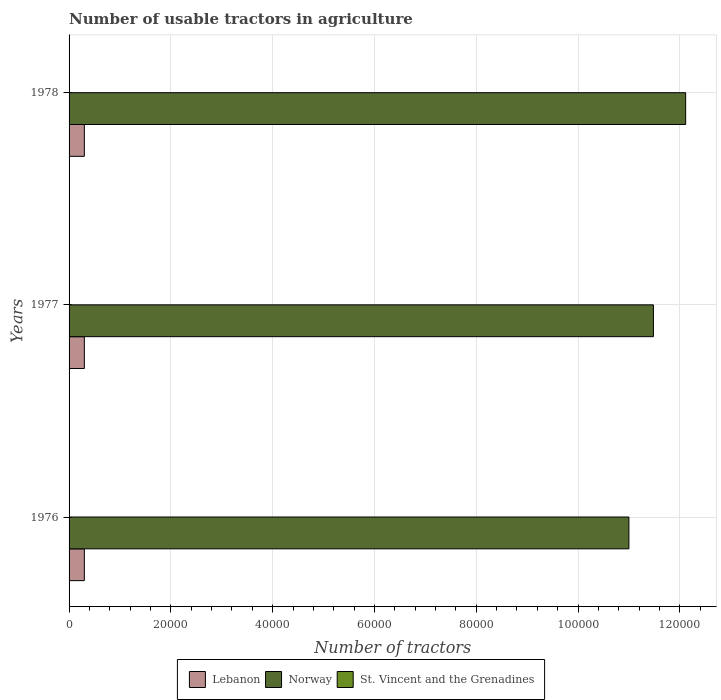How many groups of bars are there?
Make the answer very short. 3. Are the number of bars per tick equal to the number of legend labels?
Offer a very short reply. Yes. Are the number of bars on each tick of the Y-axis equal?
Your answer should be compact. Yes. How many bars are there on the 1st tick from the top?
Offer a very short reply. 3. How many bars are there on the 3rd tick from the bottom?
Offer a terse response. 3. What is the number of usable tractors in agriculture in Lebanon in 1977?
Provide a short and direct response. 3000. Across all years, what is the maximum number of usable tractors in agriculture in Lebanon?
Make the answer very short. 3000. Across all years, what is the minimum number of usable tractors in agriculture in Lebanon?
Offer a very short reply. 3000. In which year was the number of usable tractors in agriculture in Lebanon maximum?
Offer a terse response. 1976. In which year was the number of usable tractors in agriculture in Lebanon minimum?
Give a very brief answer. 1976. What is the total number of usable tractors in agriculture in St. Vincent and the Grenadines in the graph?
Make the answer very short. 219. What is the difference between the number of usable tractors in agriculture in St. Vincent and the Grenadines in 1976 and that in 1977?
Offer a very short reply. -1. What is the difference between the number of usable tractors in agriculture in Norway in 1978 and the number of usable tractors in agriculture in St. Vincent and the Grenadines in 1976?
Give a very brief answer. 1.21e+05. What is the average number of usable tractors in agriculture in Norway per year?
Offer a terse response. 1.15e+05. In the year 1977, what is the difference between the number of usable tractors in agriculture in St. Vincent and the Grenadines and number of usable tractors in agriculture in Norway?
Provide a short and direct response. -1.15e+05. What is the ratio of the number of usable tractors in agriculture in St. Vincent and the Grenadines in 1976 to that in 1977?
Provide a short and direct response. 0.99. Is the number of usable tractors in agriculture in Lebanon in 1976 less than that in 1977?
Keep it short and to the point. No. What is the difference between the highest and the second highest number of usable tractors in agriculture in Lebanon?
Your response must be concise. 0. What is the difference between the highest and the lowest number of usable tractors in agriculture in Norway?
Offer a very short reply. 1.12e+04. What does the 3rd bar from the top in 1978 represents?
Keep it short and to the point. Lebanon. What does the 3rd bar from the bottom in 1976 represents?
Your answer should be compact. St. Vincent and the Grenadines. Is it the case that in every year, the sum of the number of usable tractors in agriculture in St. Vincent and the Grenadines and number of usable tractors in agriculture in Norway is greater than the number of usable tractors in agriculture in Lebanon?
Provide a succinct answer. Yes. Does the graph contain any zero values?
Offer a very short reply. No. Does the graph contain grids?
Give a very brief answer. Yes. How many legend labels are there?
Offer a terse response. 3. What is the title of the graph?
Offer a terse response. Number of usable tractors in agriculture. What is the label or title of the X-axis?
Provide a short and direct response. Number of tractors. What is the Number of tractors of Lebanon in 1976?
Ensure brevity in your answer.  3000. What is the Number of tractors of Norway in 1976?
Give a very brief answer. 1.10e+05. What is the Number of tractors of Lebanon in 1977?
Keep it short and to the point. 3000. What is the Number of tractors in Norway in 1977?
Your response must be concise. 1.15e+05. What is the Number of tractors of St. Vincent and the Grenadines in 1977?
Ensure brevity in your answer.  73. What is the Number of tractors in Lebanon in 1978?
Give a very brief answer. 3000. What is the Number of tractors of Norway in 1978?
Offer a terse response. 1.21e+05. Across all years, what is the maximum Number of tractors of Lebanon?
Your response must be concise. 3000. Across all years, what is the maximum Number of tractors of Norway?
Your answer should be compact. 1.21e+05. Across all years, what is the minimum Number of tractors in Lebanon?
Your answer should be very brief. 3000. Across all years, what is the minimum Number of tractors in Norway?
Provide a succinct answer. 1.10e+05. What is the total Number of tractors of Lebanon in the graph?
Provide a succinct answer. 9000. What is the total Number of tractors of Norway in the graph?
Provide a short and direct response. 3.46e+05. What is the total Number of tractors of St. Vincent and the Grenadines in the graph?
Provide a short and direct response. 219. What is the difference between the Number of tractors in Norway in 1976 and that in 1977?
Make the answer very short. -4816. What is the difference between the Number of tractors in St. Vincent and the Grenadines in 1976 and that in 1977?
Offer a very short reply. -1. What is the difference between the Number of tractors of Norway in 1976 and that in 1978?
Provide a succinct answer. -1.12e+04. What is the difference between the Number of tractors of St. Vincent and the Grenadines in 1976 and that in 1978?
Make the answer very short. -2. What is the difference between the Number of tractors of Norway in 1977 and that in 1978?
Ensure brevity in your answer.  -6335. What is the difference between the Number of tractors in Lebanon in 1976 and the Number of tractors in Norway in 1977?
Give a very brief answer. -1.12e+05. What is the difference between the Number of tractors in Lebanon in 1976 and the Number of tractors in St. Vincent and the Grenadines in 1977?
Ensure brevity in your answer.  2927. What is the difference between the Number of tractors in Norway in 1976 and the Number of tractors in St. Vincent and the Grenadines in 1977?
Your answer should be very brief. 1.10e+05. What is the difference between the Number of tractors of Lebanon in 1976 and the Number of tractors of Norway in 1978?
Your answer should be very brief. -1.18e+05. What is the difference between the Number of tractors in Lebanon in 1976 and the Number of tractors in St. Vincent and the Grenadines in 1978?
Give a very brief answer. 2926. What is the difference between the Number of tractors of Norway in 1976 and the Number of tractors of St. Vincent and the Grenadines in 1978?
Offer a terse response. 1.10e+05. What is the difference between the Number of tractors in Lebanon in 1977 and the Number of tractors in Norway in 1978?
Your answer should be compact. -1.18e+05. What is the difference between the Number of tractors in Lebanon in 1977 and the Number of tractors in St. Vincent and the Grenadines in 1978?
Your answer should be very brief. 2926. What is the difference between the Number of tractors in Norway in 1977 and the Number of tractors in St. Vincent and the Grenadines in 1978?
Your answer should be very brief. 1.15e+05. What is the average Number of tractors of Lebanon per year?
Offer a terse response. 3000. What is the average Number of tractors of Norway per year?
Your response must be concise. 1.15e+05. What is the average Number of tractors in St. Vincent and the Grenadines per year?
Your answer should be very brief. 73. In the year 1976, what is the difference between the Number of tractors in Lebanon and Number of tractors in Norway?
Keep it short and to the point. -1.07e+05. In the year 1976, what is the difference between the Number of tractors in Lebanon and Number of tractors in St. Vincent and the Grenadines?
Make the answer very short. 2928. In the year 1976, what is the difference between the Number of tractors of Norway and Number of tractors of St. Vincent and the Grenadines?
Keep it short and to the point. 1.10e+05. In the year 1977, what is the difference between the Number of tractors in Lebanon and Number of tractors in Norway?
Offer a very short reply. -1.12e+05. In the year 1977, what is the difference between the Number of tractors of Lebanon and Number of tractors of St. Vincent and the Grenadines?
Your answer should be compact. 2927. In the year 1977, what is the difference between the Number of tractors of Norway and Number of tractors of St. Vincent and the Grenadines?
Make the answer very short. 1.15e+05. In the year 1978, what is the difference between the Number of tractors of Lebanon and Number of tractors of Norway?
Your answer should be very brief. -1.18e+05. In the year 1978, what is the difference between the Number of tractors in Lebanon and Number of tractors in St. Vincent and the Grenadines?
Provide a succinct answer. 2926. In the year 1978, what is the difference between the Number of tractors of Norway and Number of tractors of St. Vincent and the Grenadines?
Ensure brevity in your answer.  1.21e+05. What is the ratio of the Number of tractors in Lebanon in 1976 to that in 1977?
Offer a very short reply. 1. What is the ratio of the Number of tractors of Norway in 1976 to that in 1977?
Your answer should be compact. 0.96. What is the ratio of the Number of tractors in St. Vincent and the Grenadines in 1976 to that in 1977?
Your response must be concise. 0.99. What is the ratio of the Number of tractors of Norway in 1976 to that in 1978?
Offer a very short reply. 0.91. What is the ratio of the Number of tractors of St. Vincent and the Grenadines in 1976 to that in 1978?
Your answer should be compact. 0.97. What is the ratio of the Number of tractors of Lebanon in 1977 to that in 1978?
Keep it short and to the point. 1. What is the ratio of the Number of tractors in Norway in 1977 to that in 1978?
Ensure brevity in your answer.  0.95. What is the ratio of the Number of tractors in St. Vincent and the Grenadines in 1977 to that in 1978?
Ensure brevity in your answer.  0.99. What is the difference between the highest and the second highest Number of tractors of Norway?
Offer a very short reply. 6335. What is the difference between the highest and the second highest Number of tractors in St. Vincent and the Grenadines?
Give a very brief answer. 1. What is the difference between the highest and the lowest Number of tractors of Norway?
Offer a very short reply. 1.12e+04. 